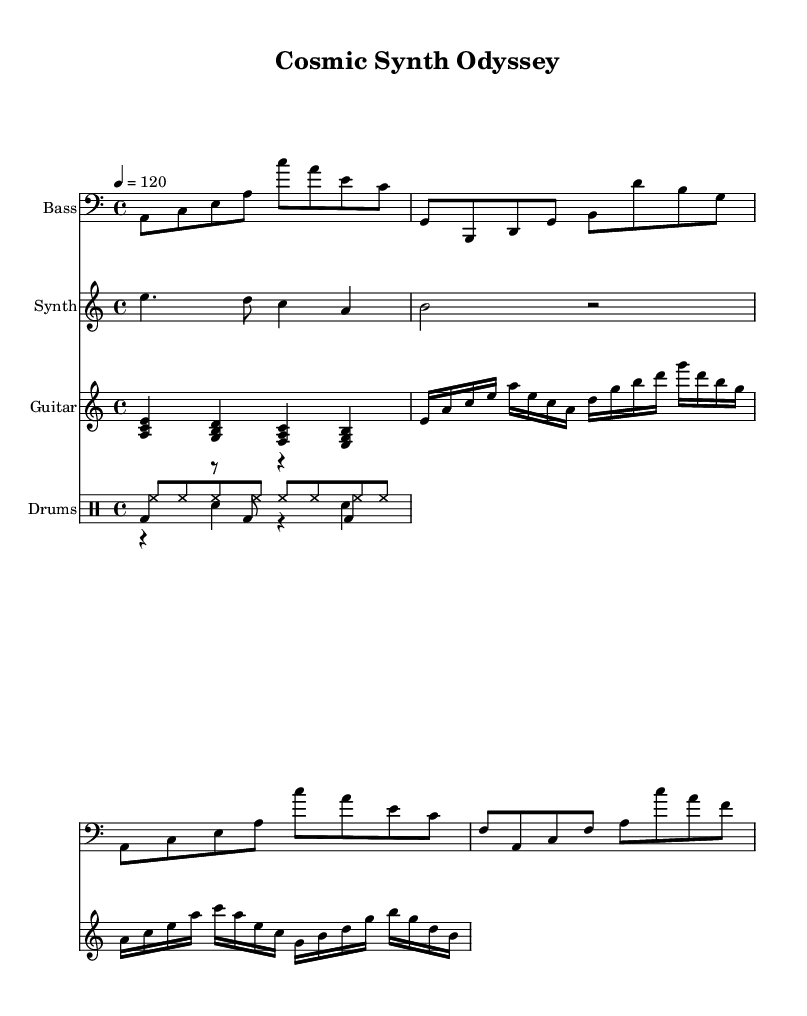What is the key signature of this music? The key signature is A minor, which has no sharps or flats, as indicated by the absence of any sharp or flat symbols on the staff.
Answer: A minor What is the time signature of this music? The time signature is 4/4, which is shown at the beginning of the score as the fraction above the staff, indicating that there are four beats in each measure and the quarter note gets one beat.
Answer: 4/4 What is the tempo marking for this piece? The tempo marking is 120 beats per minute, noted as "4 = 120" at the beginning of the score. This indicates how fast the beats are to be played.
Answer: 120 How many measures are in the bass guitar part? The bass guitar part contains four measures, which can be counted by the groupings of vertical lines (bar lines) crossing the staff.
Answer: 4 Which instruments are used in this score? The instruments used in this score are Bass, Synth, Guitar, and Drums, all of which are clearly indicated with their respective names above the staves.
Answer: Bass, Synth, Guitar, Drums What type of rhythmic pattern does the hi-hat play? The hi-hat plays a steady eighth note rhythm, indicated by the repetition of "hh" for each eighth note in the drum section of the score, creating a continuous pulse.
Answer: Eighth note rhythm What is the overall texture of the music? The overall texture of the music is polyphonic, as it features multiple independent melodic lines from the bass, synthesizer, and electric guitar parts, as well as layered drum patterns, creating a rich sound typical of experimental electronic fusion.
Answer: Polyphonic 